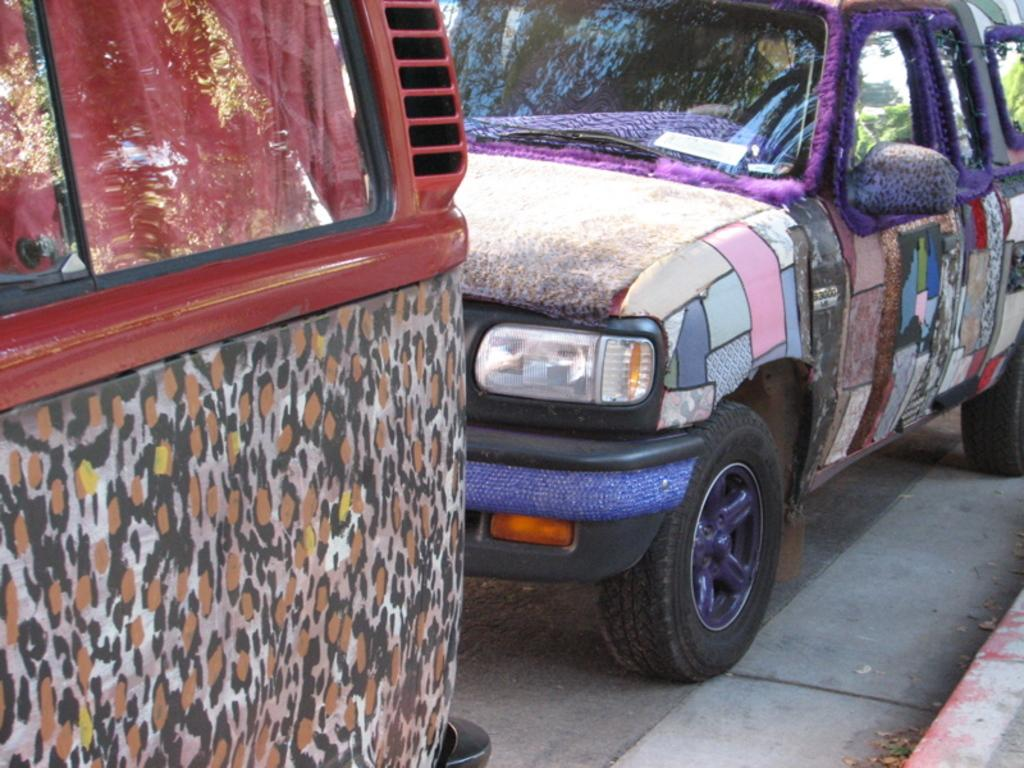What can be seen on the road in the image? There are vehicles on the road in the image. Where is the cannon located in the image? There is no cannon present in the image. What sign can be seen on the road in the image? The provided facts do not mention any signs on the road in the image. 